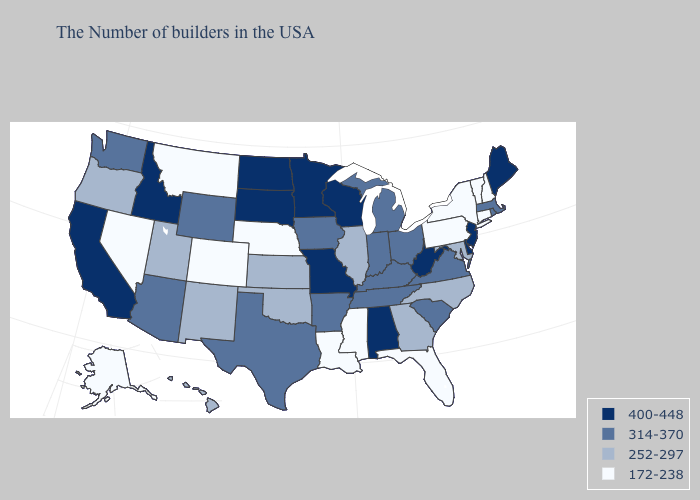What is the value of Maryland?
Keep it brief. 252-297. Name the states that have a value in the range 252-297?
Give a very brief answer. Maryland, North Carolina, Georgia, Illinois, Kansas, Oklahoma, New Mexico, Utah, Oregon, Hawaii. Name the states that have a value in the range 314-370?
Be succinct. Massachusetts, Rhode Island, Virginia, South Carolina, Ohio, Michigan, Kentucky, Indiana, Tennessee, Arkansas, Iowa, Texas, Wyoming, Arizona, Washington. What is the value of Louisiana?
Short answer required. 172-238. Which states have the highest value in the USA?
Be succinct. Maine, New Jersey, Delaware, West Virginia, Alabama, Wisconsin, Missouri, Minnesota, South Dakota, North Dakota, Idaho, California. Name the states that have a value in the range 252-297?
Write a very short answer. Maryland, North Carolina, Georgia, Illinois, Kansas, Oklahoma, New Mexico, Utah, Oregon, Hawaii. Does Alaska have the same value as Montana?
Keep it brief. Yes. Does Maryland have the highest value in the South?
Write a very short answer. No. Does North Carolina have the lowest value in the USA?
Concise answer only. No. Does Vermont have the lowest value in the Northeast?
Short answer required. Yes. Does the first symbol in the legend represent the smallest category?
Short answer required. No. What is the lowest value in the Northeast?
Be succinct. 172-238. Among the states that border Georgia , which have the lowest value?
Be succinct. Florida. Does Massachusetts have a higher value than Connecticut?
Concise answer only. Yes. What is the value of Missouri?
Short answer required. 400-448. 